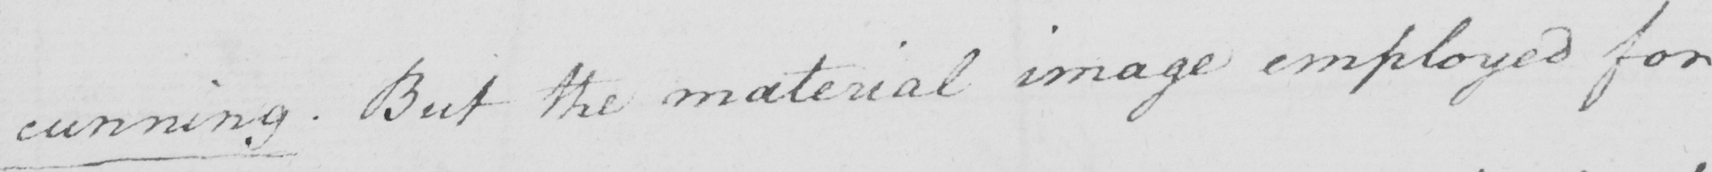Transcribe the text shown in this historical manuscript line. cunning . But the material image employed for 